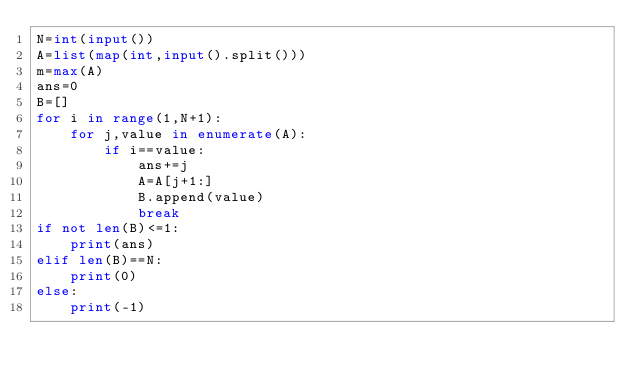Convert code to text. <code><loc_0><loc_0><loc_500><loc_500><_Python_>N=int(input())
A=list(map(int,input().split()))
m=max(A)
ans=0
B=[]
for i in range(1,N+1):
    for j,value in enumerate(A):
        if i==value:
            ans+=j
            A=A[j+1:]
            B.append(value)
            break
if not len(B)<=1:
    print(ans)
elif len(B)==N:
    print(0)
else:
    print(-1)</code> 